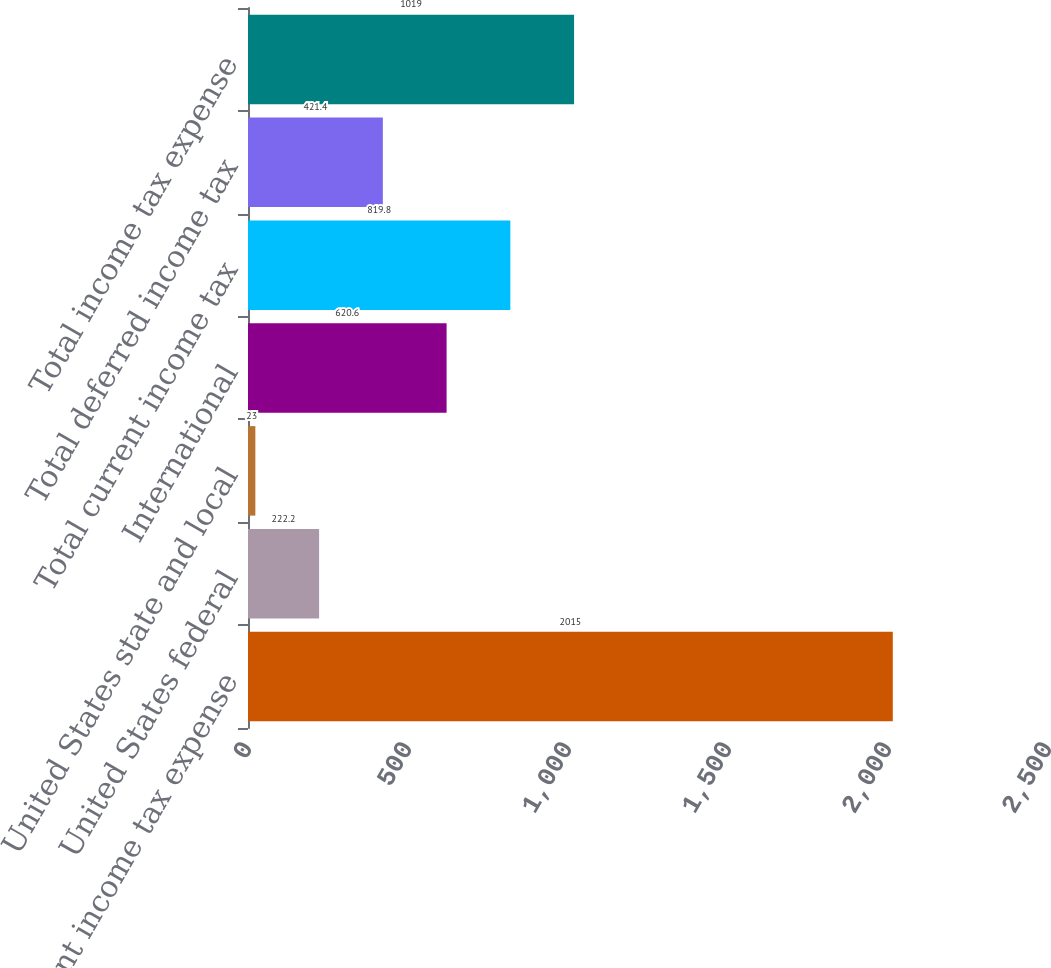Convert chart to OTSL. <chart><loc_0><loc_0><loc_500><loc_500><bar_chart><fcel>Current income tax expense<fcel>United States federal<fcel>United States state and local<fcel>International<fcel>Total current income tax<fcel>Total deferred income tax<fcel>Total income tax expense<nl><fcel>2015<fcel>222.2<fcel>23<fcel>620.6<fcel>819.8<fcel>421.4<fcel>1019<nl></chart> 